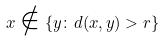<formula> <loc_0><loc_0><loc_500><loc_500>x \notin \{ y \colon d ( x , y ) > r \}</formula> 